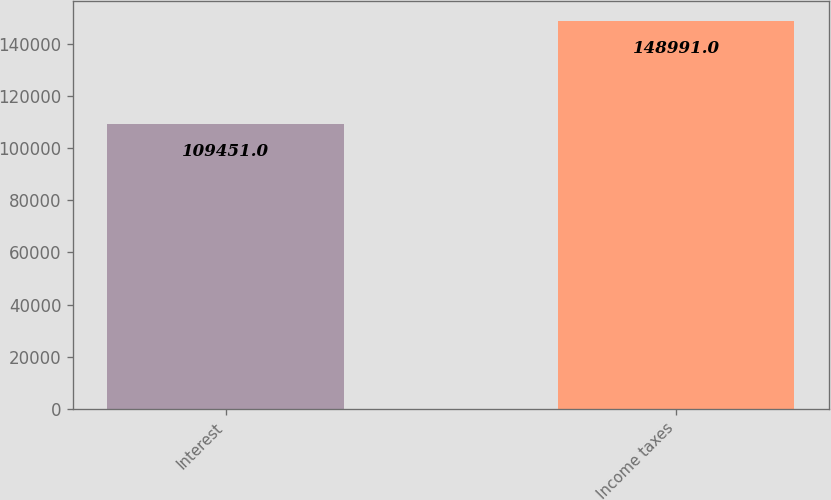Convert chart to OTSL. <chart><loc_0><loc_0><loc_500><loc_500><bar_chart><fcel>Interest<fcel>Income taxes<nl><fcel>109451<fcel>148991<nl></chart> 